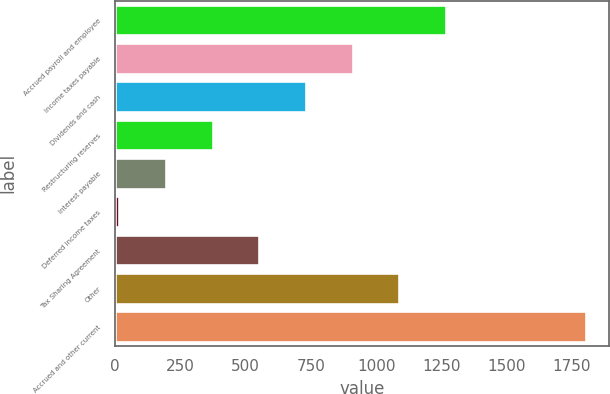Convert chart. <chart><loc_0><loc_0><loc_500><loc_500><bar_chart><fcel>Accrued payroll and employee<fcel>Income taxes payable<fcel>Dividends and cash<fcel>Restructuring reserves<fcel>Interest payable<fcel>Deferred income taxes<fcel>Tax Sharing Agreement<fcel>Other<fcel>Accrued and other current<nl><fcel>1267.6<fcel>910<fcel>731.2<fcel>373.6<fcel>194.8<fcel>16<fcel>552.4<fcel>1088.8<fcel>1804<nl></chart> 